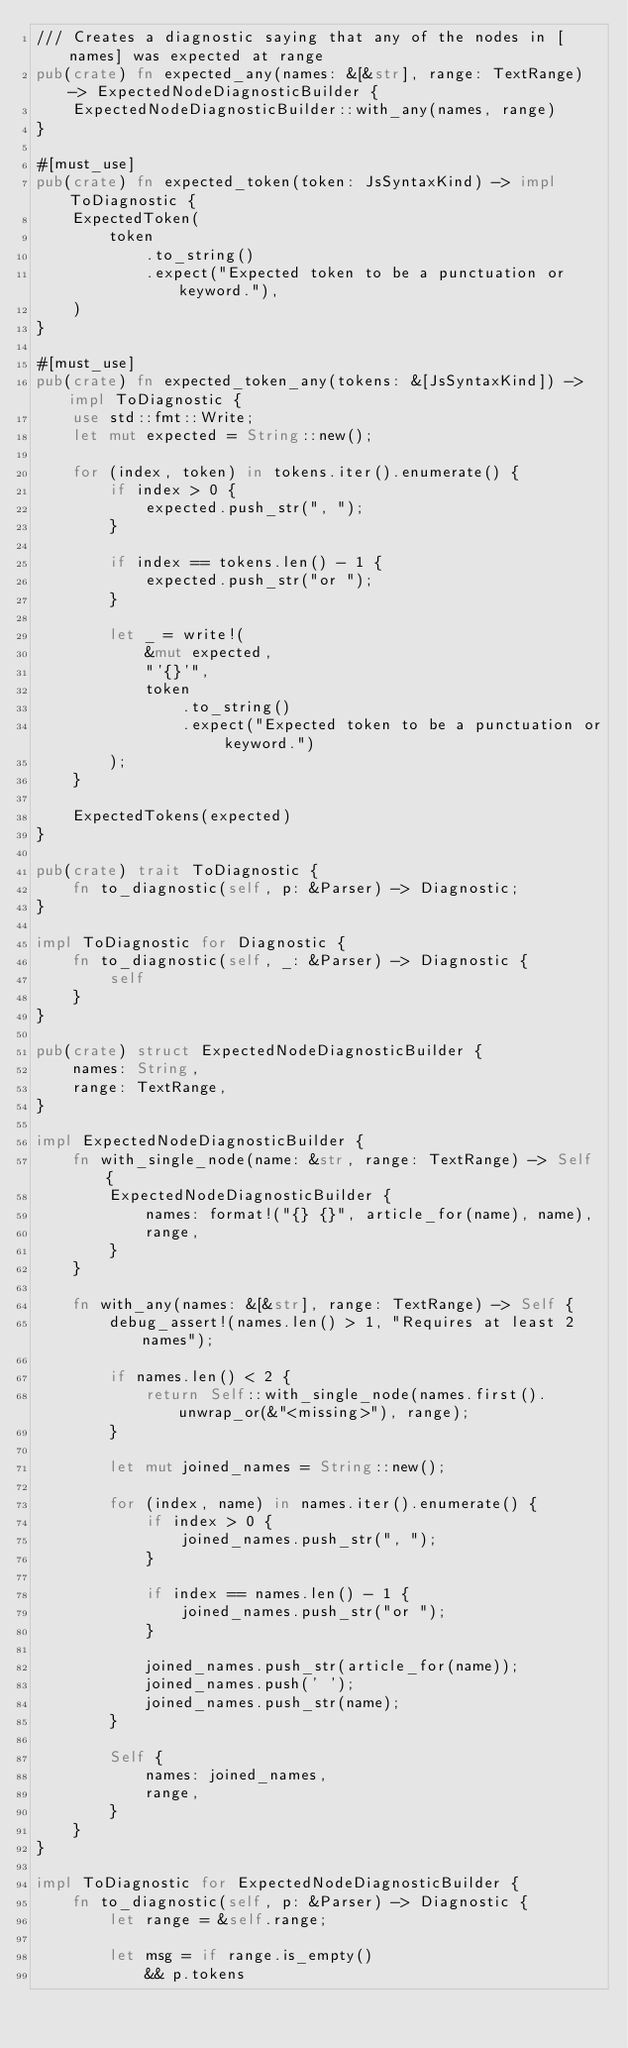Convert code to text. <code><loc_0><loc_0><loc_500><loc_500><_Rust_>/// Creates a diagnostic saying that any of the nodes in [names] was expected at range
pub(crate) fn expected_any(names: &[&str], range: TextRange) -> ExpectedNodeDiagnosticBuilder {
    ExpectedNodeDiagnosticBuilder::with_any(names, range)
}

#[must_use]
pub(crate) fn expected_token(token: JsSyntaxKind) -> impl ToDiagnostic {
    ExpectedToken(
        token
            .to_string()
            .expect("Expected token to be a punctuation or keyword."),
    )
}

#[must_use]
pub(crate) fn expected_token_any(tokens: &[JsSyntaxKind]) -> impl ToDiagnostic {
    use std::fmt::Write;
    let mut expected = String::new();

    for (index, token) in tokens.iter().enumerate() {
        if index > 0 {
            expected.push_str(", ");
        }

        if index == tokens.len() - 1 {
            expected.push_str("or ");
        }

        let _ = write!(
            &mut expected,
            "'{}'",
            token
                .to_string()
                .expect("Expected token to be a punctuation or keyword.")
        );
    }

    ExpectedTokens(expected)
}

pub(crate) trait ToDiagnostic {
    fn to_diagnostic(self, p: &Parser) -> Diagnostic;
}

impl ToDiagnostic for Diagnostic {
    fn to_diagnostic(self, _: &Parser) -> Diagnostic {
        self
    }
}

pub(crate) struct ExpectedNodeDiagnosticBuilder {
    names: String,
    range: TextRange,
}

impl ExpectedNodeDiagnosticBuilder {
    fn with_single_node(name: &str, range: TextRange) -> Self {
        ExpectedNodeDiagnosticBuilder {
            names: format!("{} {}", article_for(name), name),
            range,
        }
    }

    fn with_any(names: &[&str], range: TextRange) -> Self {
        debug_assert!(names.len() > 1, "Requires at least 2 names");

        if names.len() < 2 {
            return Self::with_single_node(names.first().unwrap_or(&"<missing>"), range);
        }

        let mut joined_names = String::new();

        for (index, name) in names.iter().enumerate() {
            if index > 0 {
                joined_names.push_str(", ");
            }

            if index == names.len() - 1 {
                joined_names.push_str("or ");
            }

            joined_names.push_str(article_for(name));
            joined_names.push(' ');
            joined_names.push_str(name);
        }

        Self {
            names: joined_names,
            range,
        }
    }
}

impl ToDiagnostic for ExpectedNodeDiagnosticBuilder {
    fn to_diagnostic(self, p: &Parser) -> Diagnostic {
        let range = &self.range;

        let msg = if range.is_empty()
            && p.tokens</code> 